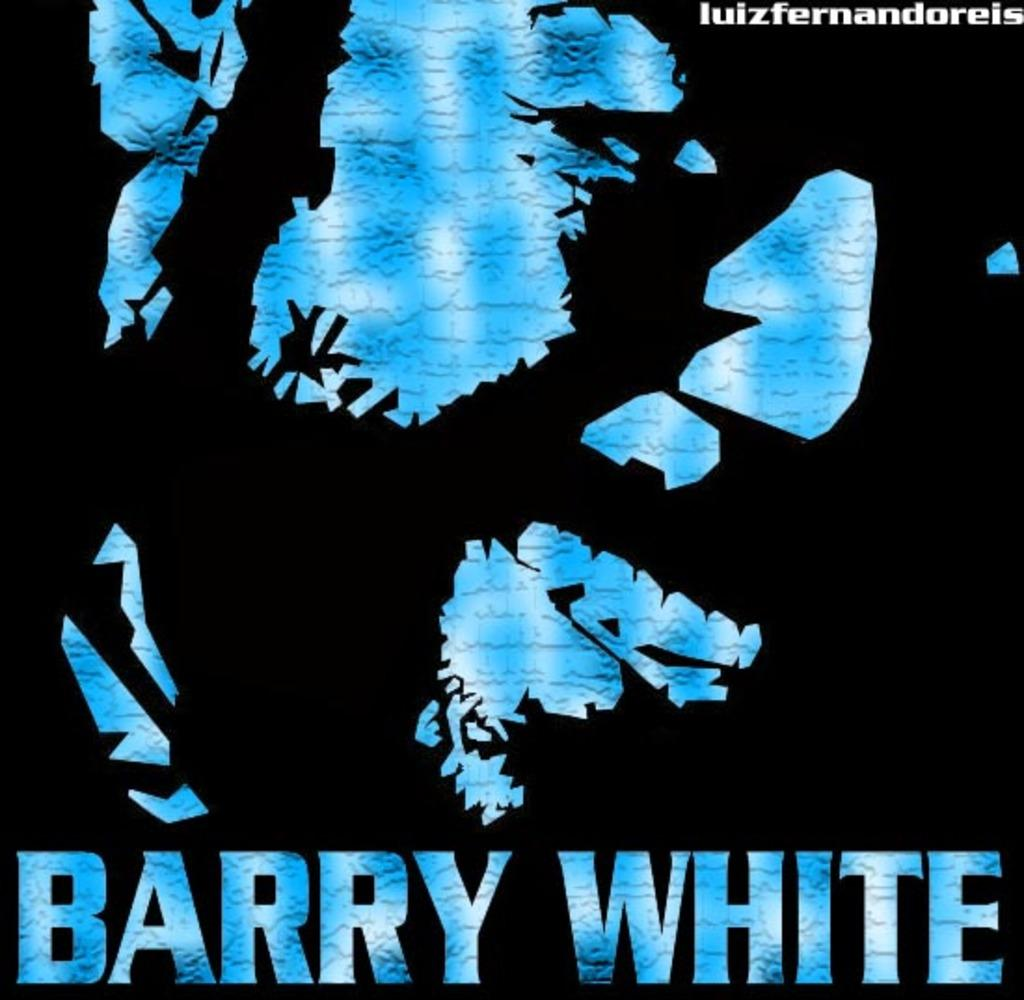What is present on the poster in the image? The poster contains text and an image. Can you describe the image on the poster? Unfortunately, the specific image on the poster cannot be described without more information. What type of information is conveyed through the text on the poster? The content of the text on the poster cannot be determined without more information. What type of apple is being used for the treatment in the image? There is no apple or treatment present in the image; it only contains a poster with text and an image. 